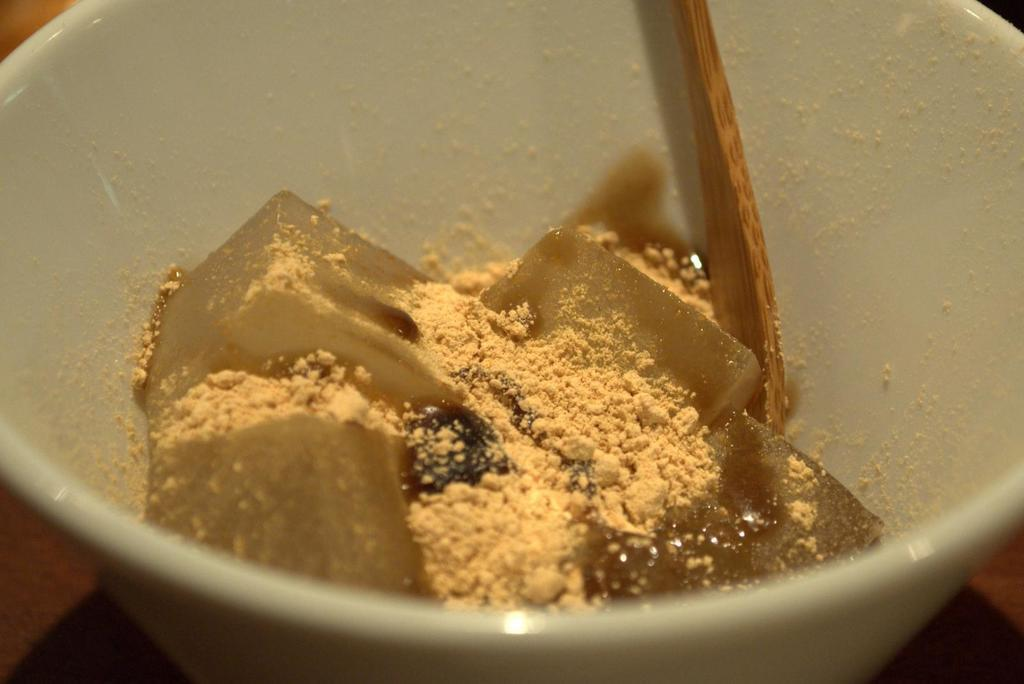What is in the bowl that is visible in the image? There is a bowl containing food in the image. What utensil is placed on the surface in the image? There is a spoon placed on the surface in the image. Can you tell me how many babies are present in the image? There is no baby present in the image; it features a bowl containing food and a spoon. What type of existence is depicted in the image? The image does not depict any specific type of existence; it simply shows a bowl containing food and a spoon. 